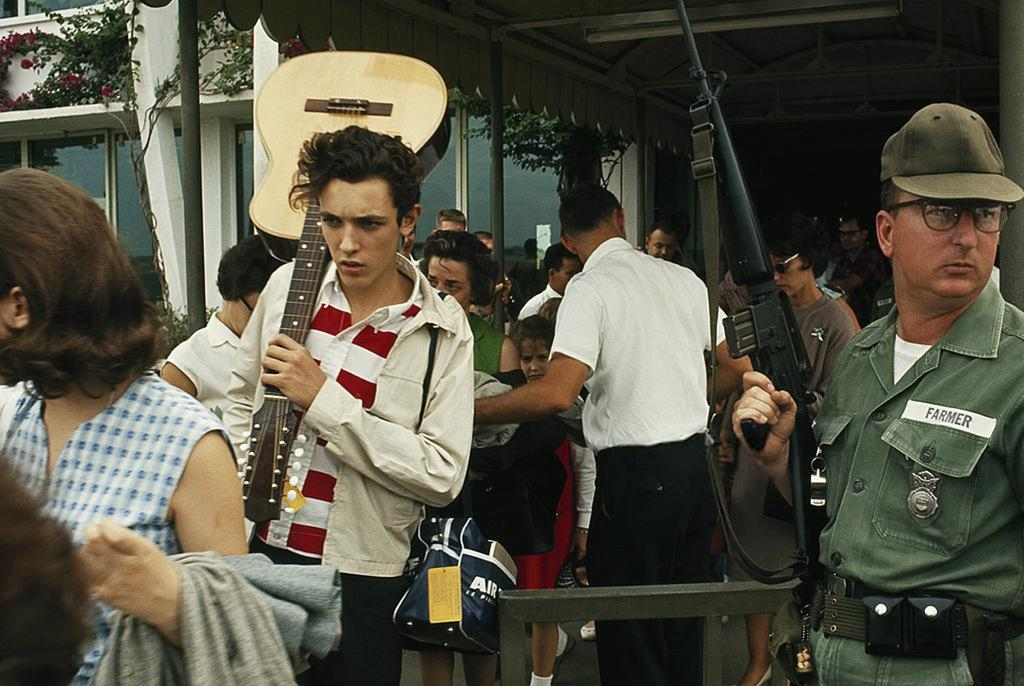How many people are in the group in the image? There is a group of people in the image, but the exact number is not specified. What is one person in the group holding? One person in the group is holding a guitar. What is another person in the group holding? Another person in the group is holding a gun. What can be seen in the background of the image? In the background of the image, there are trees and a building. What type of competition is taking place in the image? There is no indication of a competition taking place in the image. 